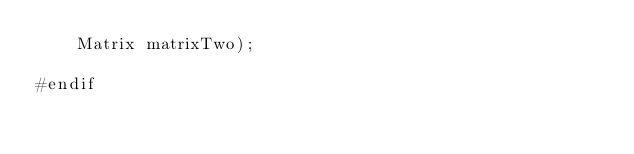Convert code to text. <code><loc_0><loc_0><loc_500><loc_500><_Cuda_>    Matrix matrixTwo);

#endif</code> 